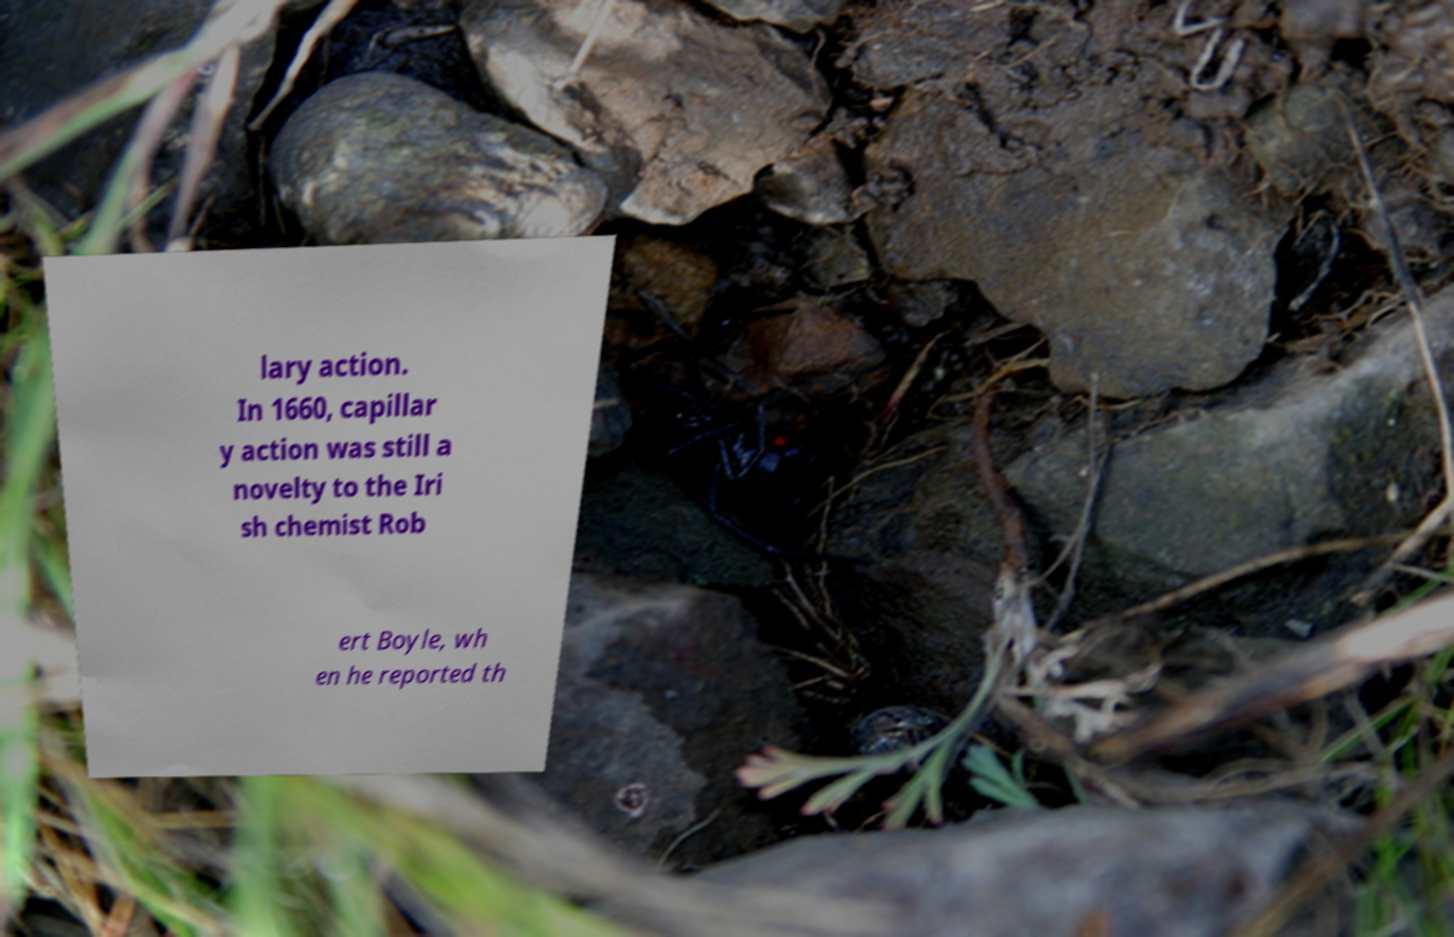For documentation purposes, I need the text within this image transcribed. Could you provide that? lary action. In 1660, capillar y action was still a novelty to the Iri sh chemist Rob ert Boyle, wh en he reported th 